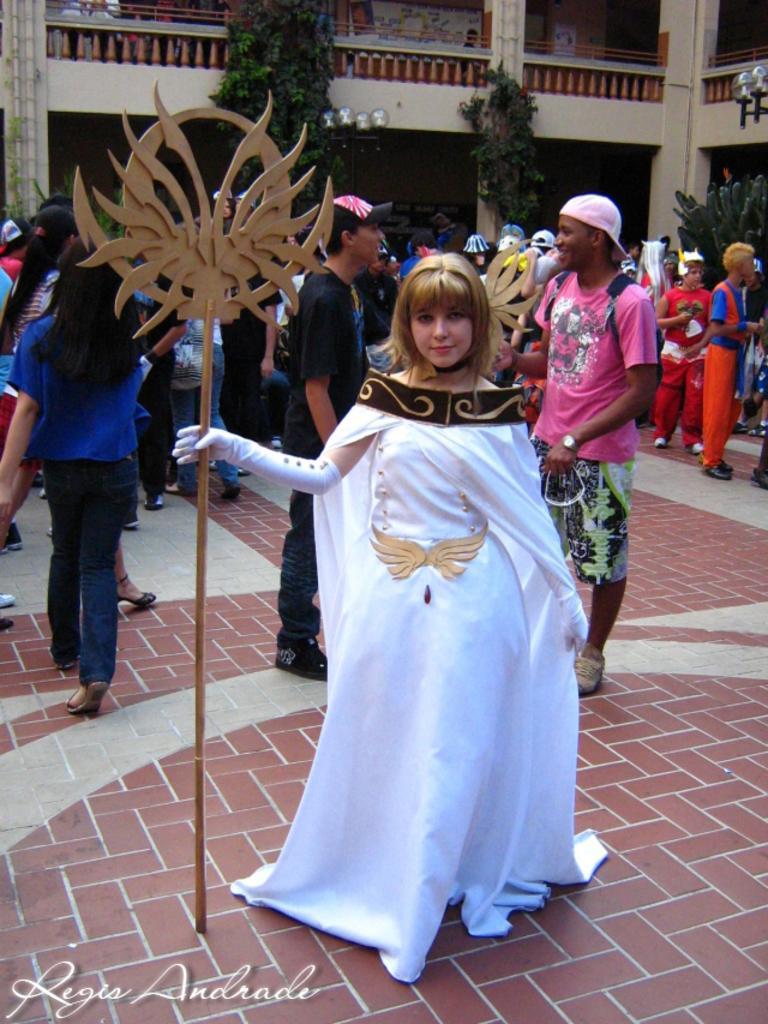In one or two sentences, can you explain what this image depicts? In this picture I can see there is a woman standing, she is wearing a white costume and holding a pole in her hand, there are a few plants and few people in the backdrop. There is a building in the backdrop. 